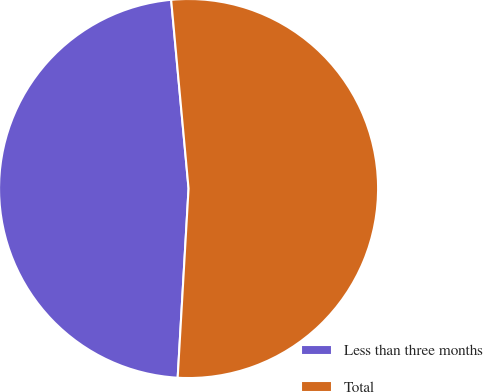Convert chart. <chart><loc_0><loc_0><loc_500><loc_500><pie_chart><fcel>Less than three months<fcel>Total<nl><fcel>47.62%<fcel>52.38%<nl></chart> 